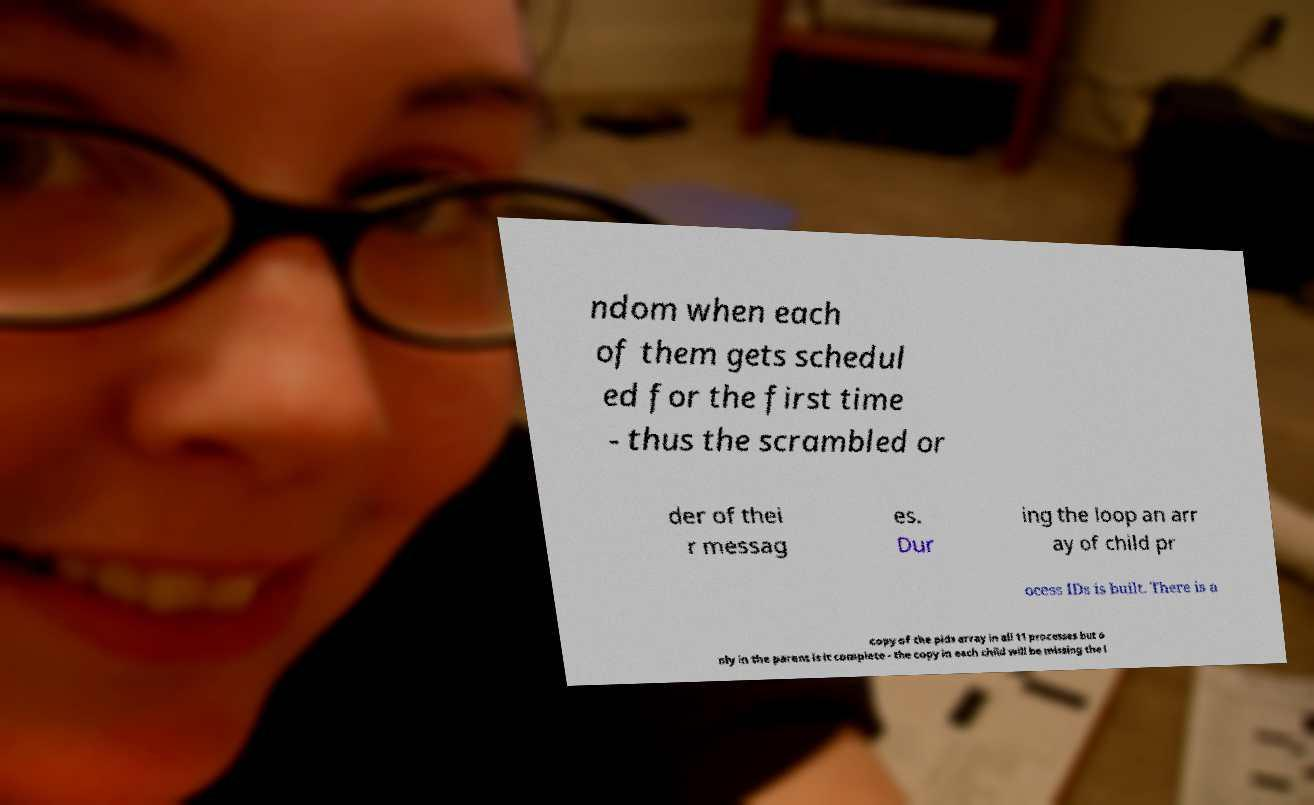Could you extract and type out the text from this image? ndom when each of them gets schedul ed for the first time - thus the scrambled or der of thei r messag es. Dur ing the loop an arr ay of child pr ocess IDs is built. There is a copy of the pids array in all 11 processes but o nly in the parent is it complete - the copy in each child will be missing the l 